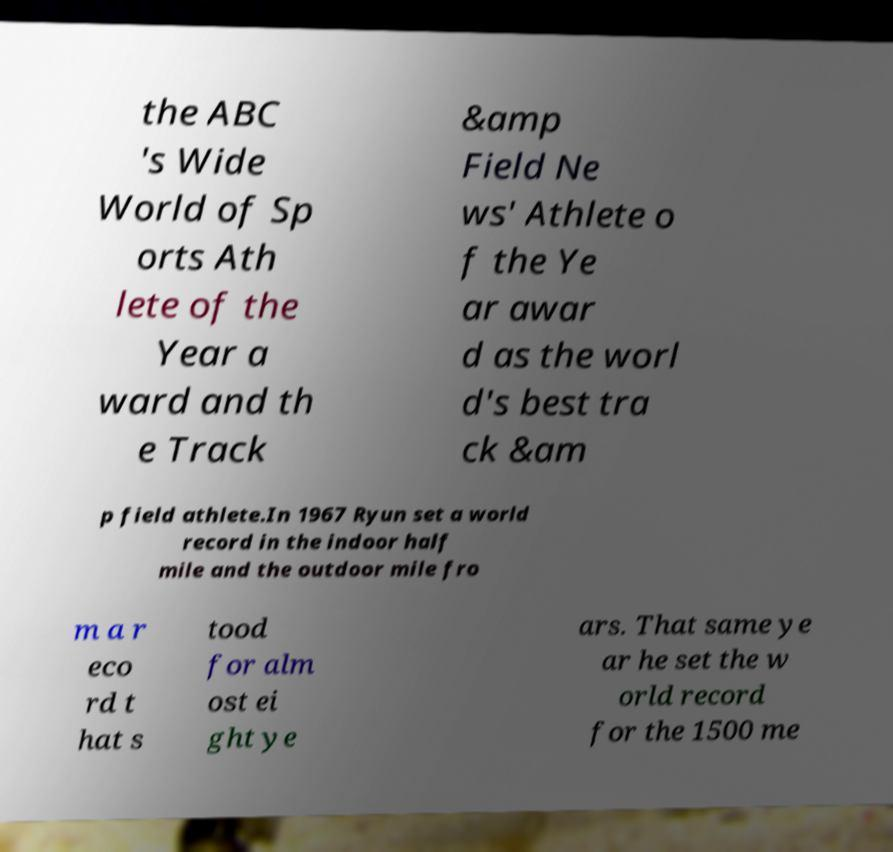Please identify and transcribe the text found in this image. the ABC 's Wide World of Sp orts Ath lete of the Year a ward and th e Track &amp Field Ne ws' Athlete o f the Ye ar awar d as the worl d's best tra ck &am p field athlete.In 1967 Ryun set a world record in the indoor half mile and the outdoor mile fro m a r eco rd t hat s tood for alm ost ei ght ye ars. That same ye ar he set the w orld record for the 1500 me 